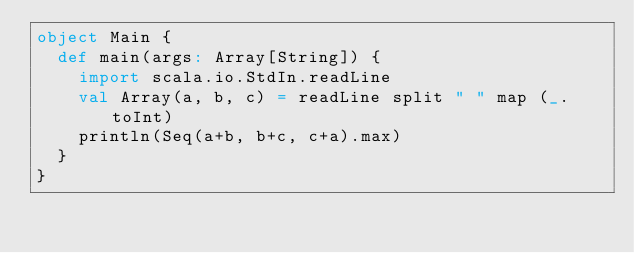<code> <loc_0><loc_0><loc_500><loc_500><_Scala_>object Main {
  def main(args: Array[String]) {
    import scala.io.StdIn.readLine
    val Array(a, b, c) = readLine split " " map (_.toInt)
    println(Seq(a+b, b+c, c+a).max)
  }
}</code> 